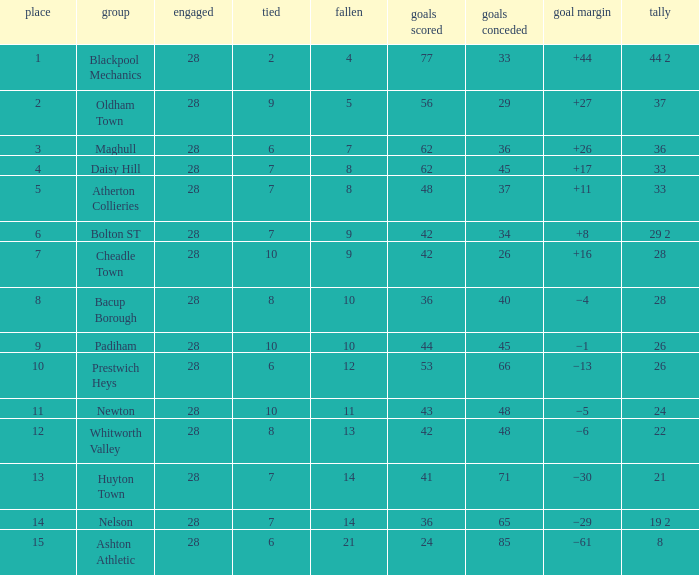What is the highest goals entry with drawn larger than 6 and goals against 85? None. 